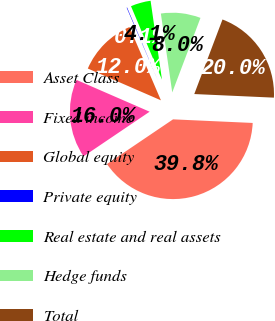Convert chart to OTSL. <chart><loc_0><loc_0><loc_500><loc_500><pie_chart><fcel>Asset Class<fcel>Fixed income<fcel>Global equity<fcel>Private equity<fcel>Real estate and real assets<fcel>Hedge funds<fcel>Total<nl><fcel>39.82%<fcel>15.99%<fcel>12.02%<fcel>0.1%<fcel>4.07%<fcel>8.04%<fcel>19.96%<nl></chart> 